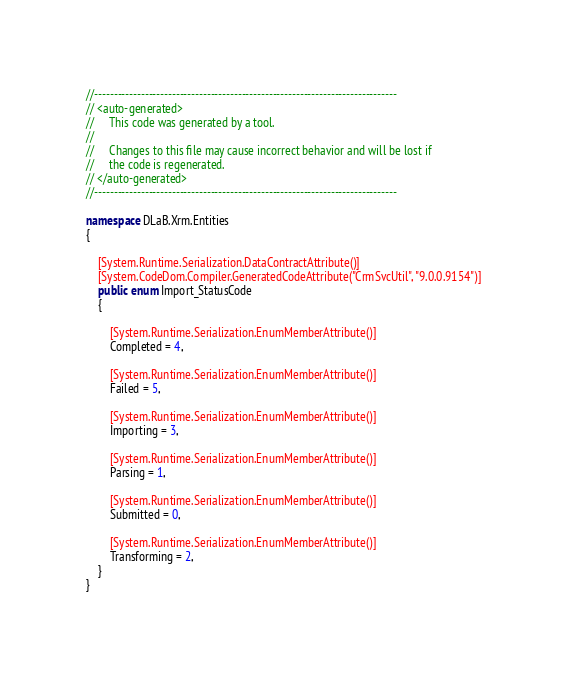<code> <loc_0><loc_0><loc_500><loc_500><_C#_>//------------------------------------------------------------------------------
// <auto-generated>
//     This code was generated by a tool.
//
//     Changes to this file may cause incorrect behavior and will be lost if
//     the code is regenerated.
// </auto-generated>
//------------------------------------------------------------------------------

namespace DLaB.Xrm.Entities
{
	
	[System.Runtime.Serialization.DataContractAttribute()]
	[System.CodeDom.Compiler.GeneratedCodeAttribute("CrmSvcUtil", "9.0.0.9154")]
	public enum Import_StatusCode
	{
		
		[System.Runtime.Serialization.EnumMemberAttribute()]
		Completed = 4,
		
		[System.Runtime.Serialization.EnumMemberAttribute()]
		Failed = 5,
		
		[System.Runtime.Serialization.EnumMemberAttribute()]
		Importing = 3,
		
		[System.Runtime.Serialization.EnumMemberAttribute()]
		Parsing = 1,
		
		[System.Runtime.Serialization.EnumMemberAttribute()]
		Submitted = 0,
		
		[System.Runtime.Serialization.EnumMemberAttribute()]
		Transforming = 2,
	}
}</code> 